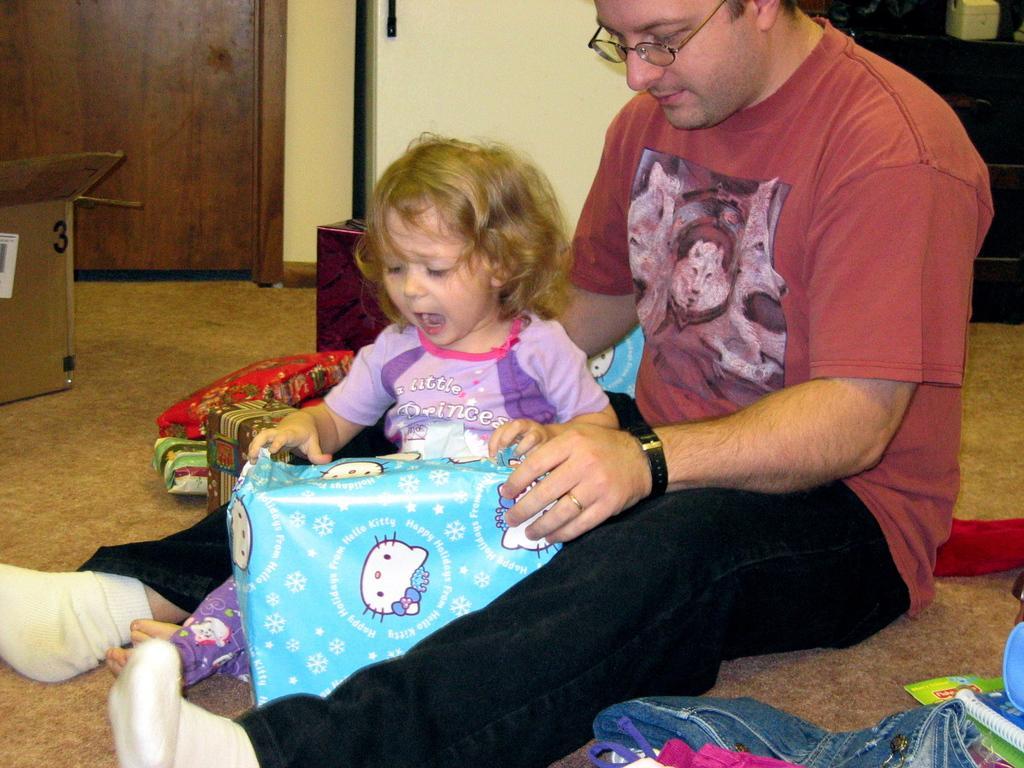Please provide a concise description of this image. In this image I can see two people with different color dresses. I can see these people are holding the gift box which is in blue and white color. To the side I can see the pant, books and few more gift boxes. To the left I can see the cardboard box. In the background I can see the wooden door and the wall. 